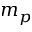<formula> <loc_0><loc_0><loc_500><loc_500>m _ { p }</formula> 